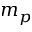<formula> <loc_0><loc_0><loc_500><loc_500>m _ { p }</formula> 